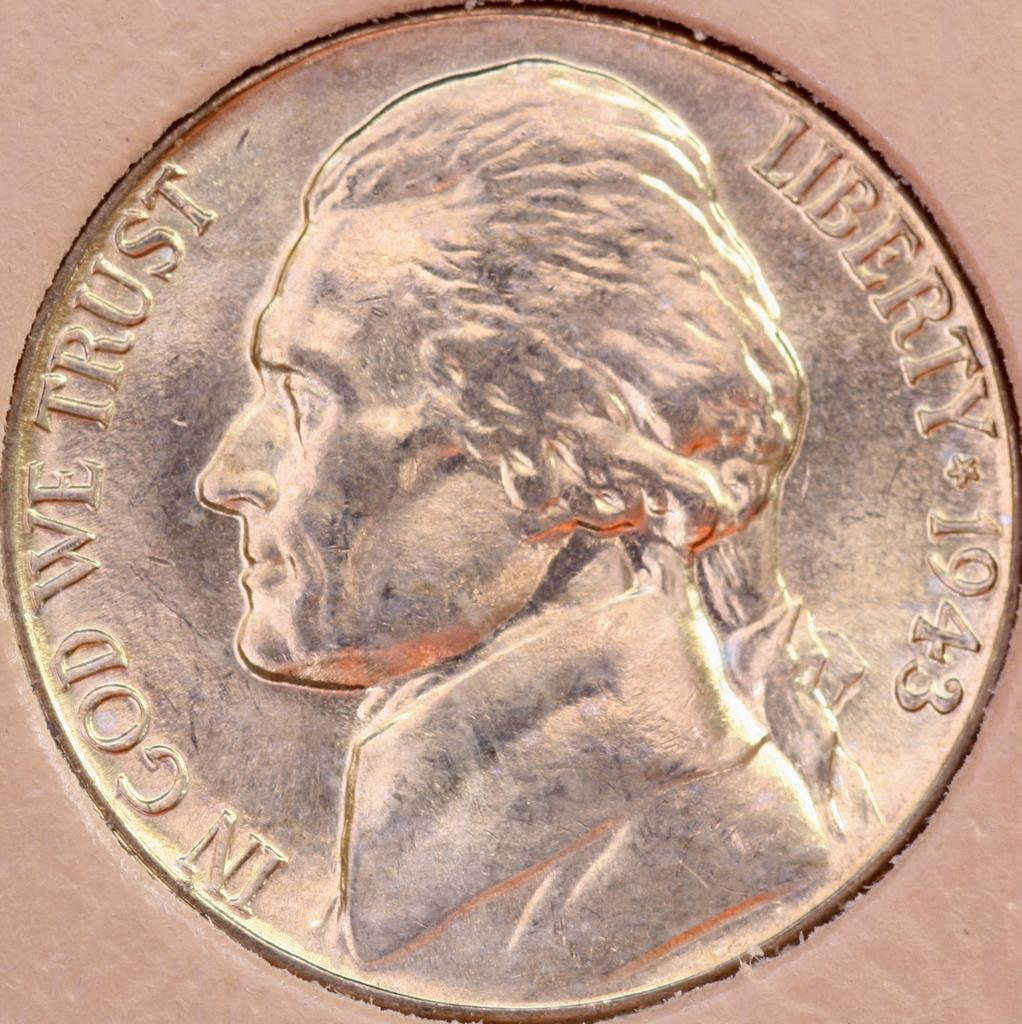<image>
Create a compact narrative representing the image presented. The front of a coin has a minting year of 1943. 